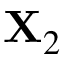<formula> <loc_0><loc_0><loc_500><loc_500>X _ { 2 }</formula> 